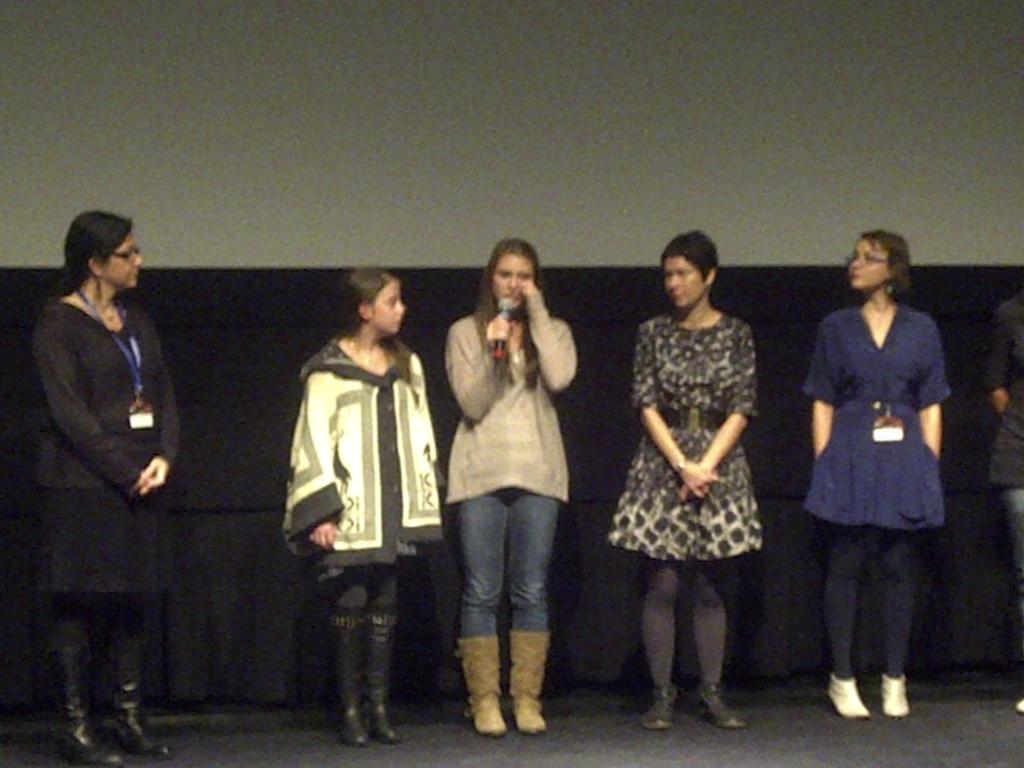Can you describe this image briefly? In this image there are six persons standing one person is holding a mic in the background there is a wall. 